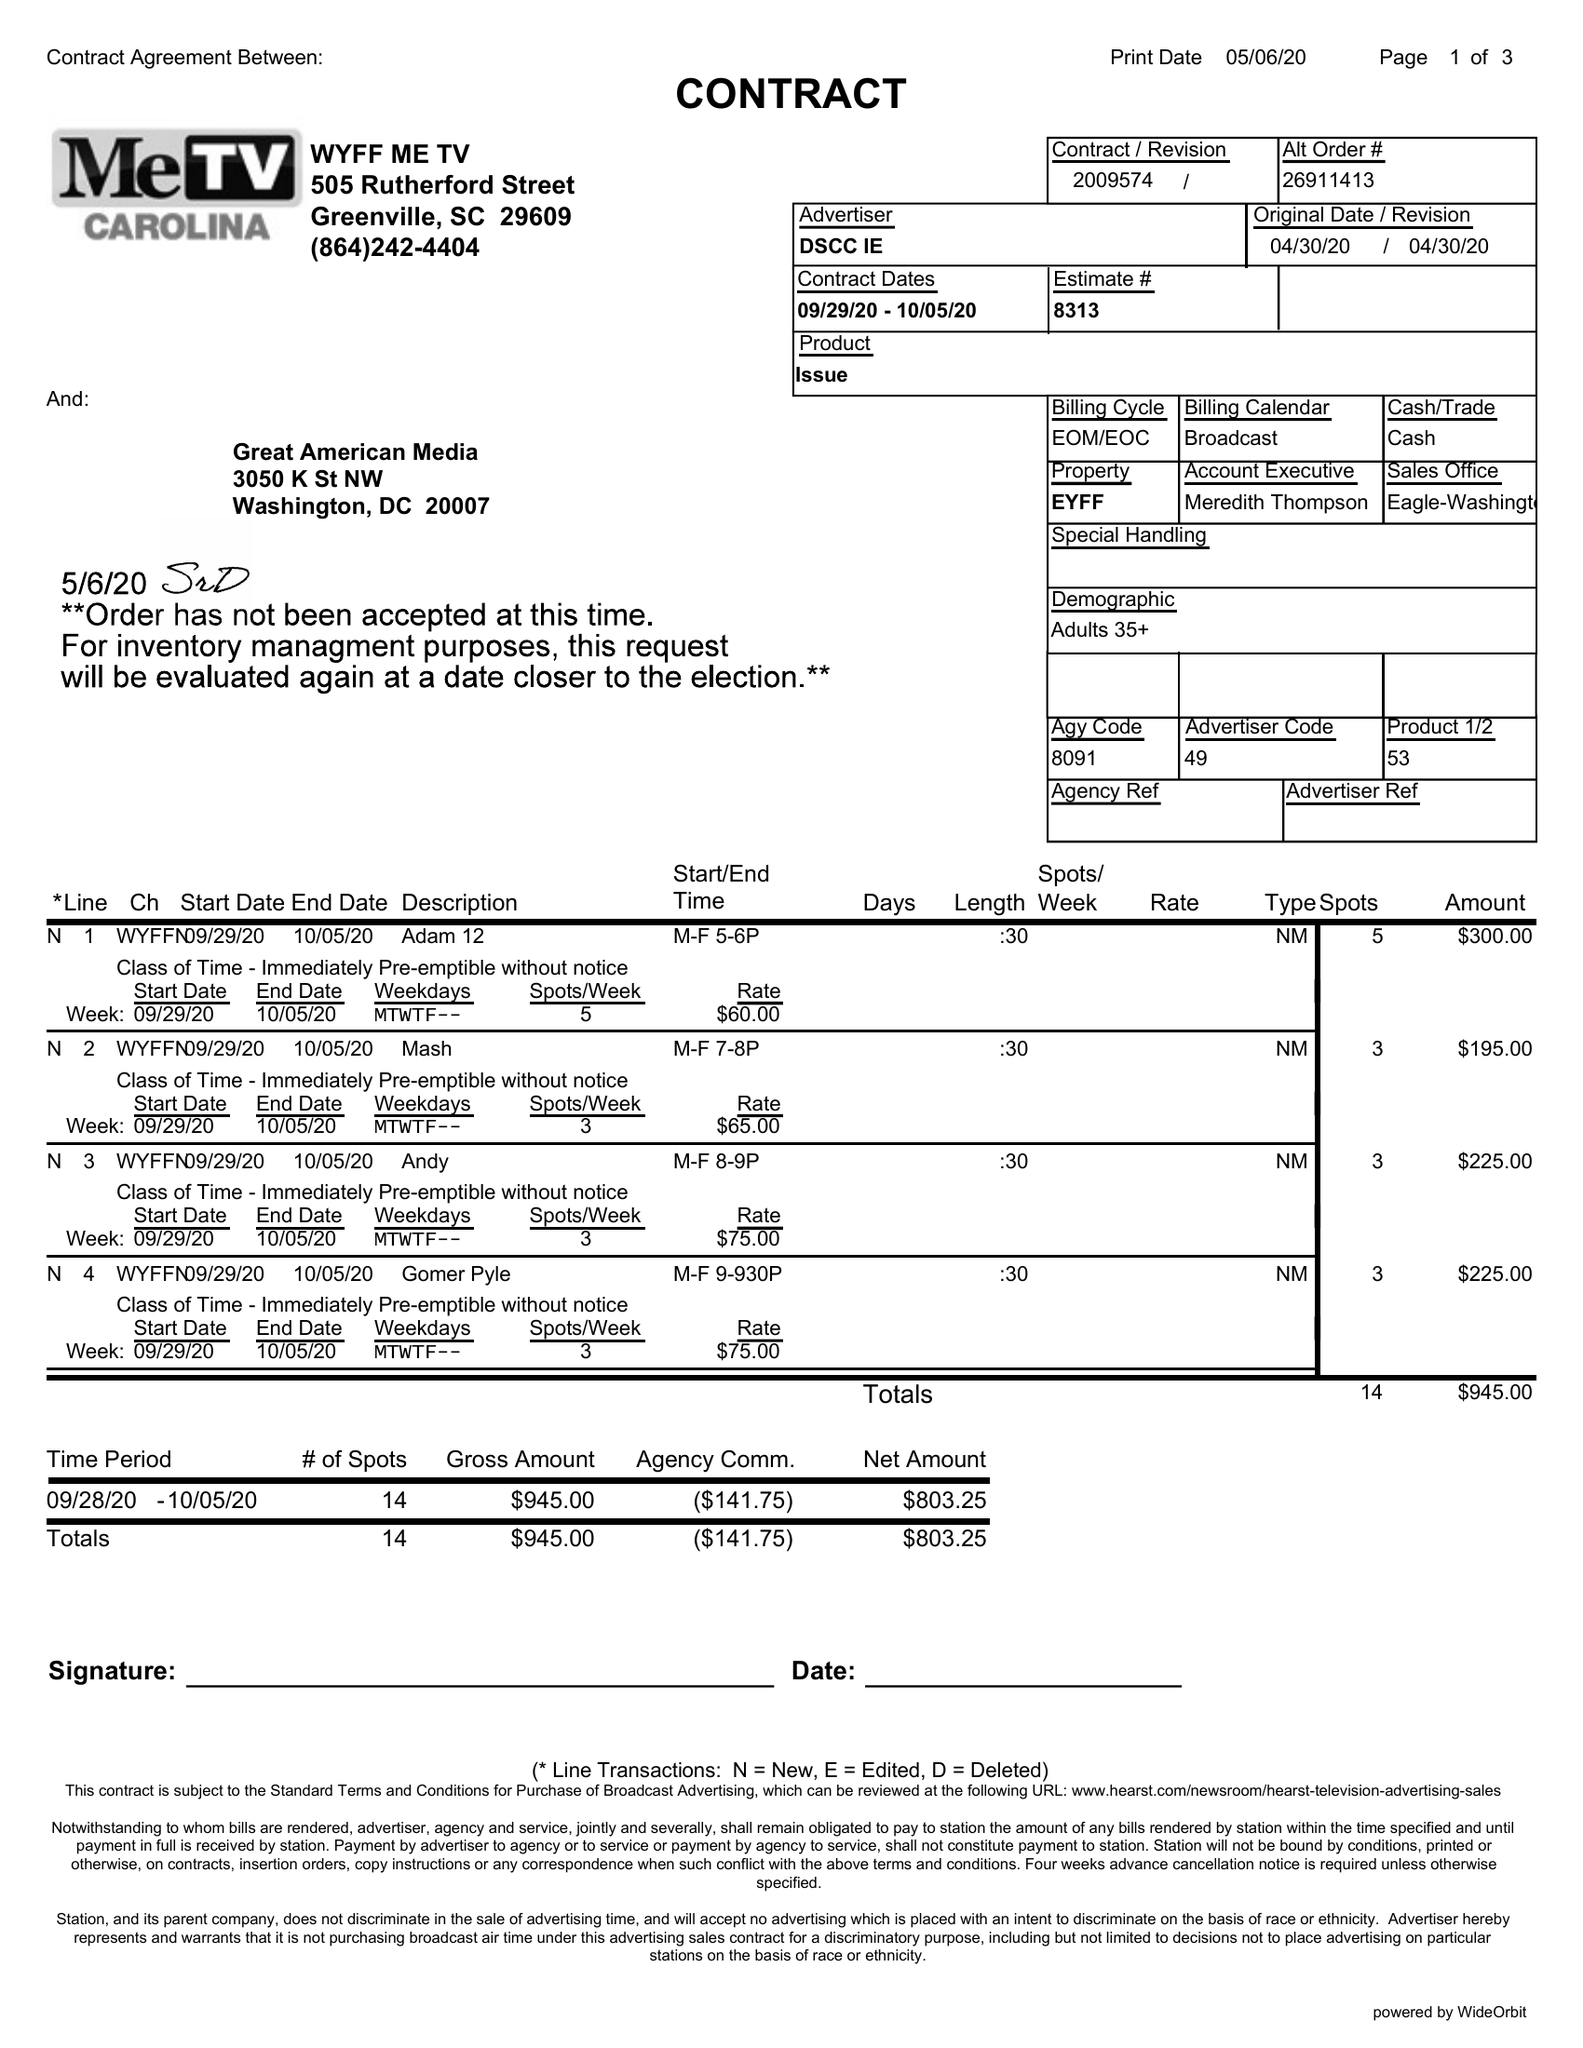What is the value for the advertiser?
Answer the question using a single word or phrase. DSCC IE 